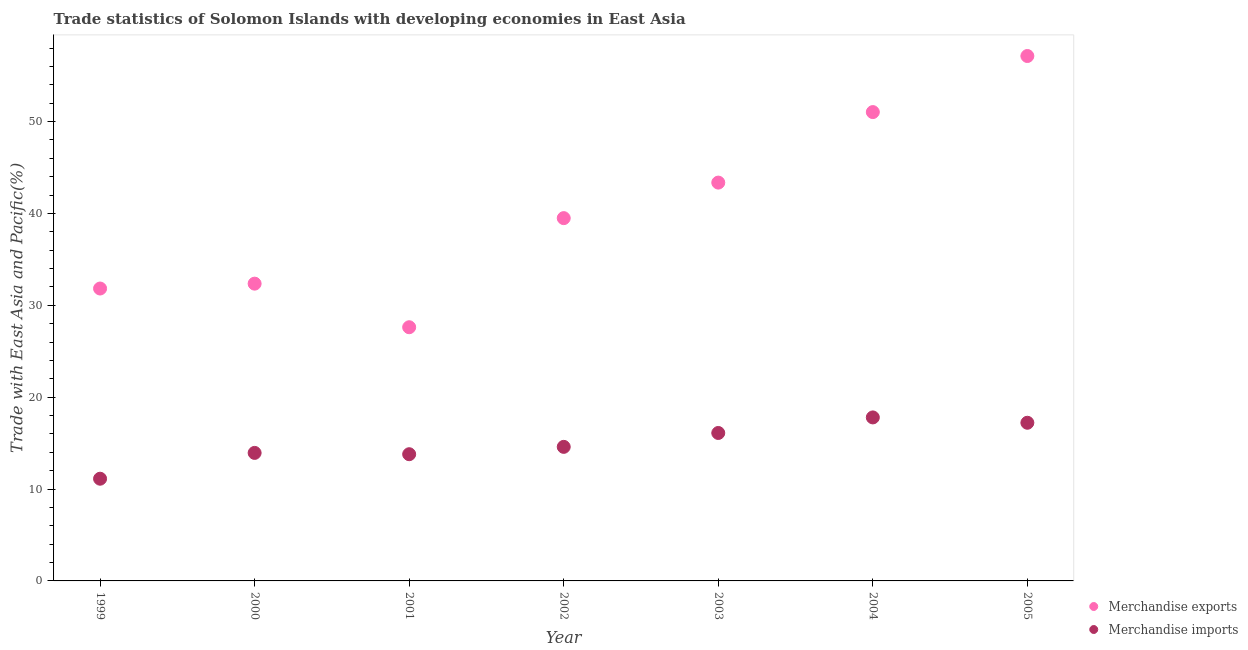What is the merchandise imports in 2001?
Provide a short and direct response. 13.79. Across all years, what is the maximum merchandise imports?
Your answer should be compact. 17.79. Across all years, what is the minimum merchandise exports?
Offer a terse response. 27.61. What is the total merchandise exports in the graph?
Your answer should be compact. 282.77. What is the difference between the merchandise exports in 2000 and that in 2004?
Offer a terse response. -18.67. What is the difference between the merchandise exports in 2002 and the merchandise imports in 2000?
Offer a very short reply. 25.55. What is the average merchandise imports per year?
Keep it short and to the point. 14.94. In the year 1999, what is the difference between the merchandise imports and merchandise exports?
Provide a succinct answer. -20.7. In how many years, is the merchandise exports greater than 28 %?
Offer a terse response. 6. What is the ratio of the merchandise imports in 2002 to that in 2004?
Provide a short and direct response. 0.82. What is the difference between the highest and the second highest merchandise imports?
Your answer should be very brief. 0.58. What is the difference between the highest and the lowest merchandise imports?
Ensure brevity in your answer.  6.67. Does the merchandise imports monotonically increase over the years?
Provide a succinct answer. No. Is the merchandise exports strictly less than the merchandise imports over the years?
Keep it short and to the point. No. How many dotlines are there?
Make the answer very short. 2. How many years are there in the graph?
Your answer should be compact. 7. Are the values on the major ticks of Y-axis written in scientific E-notation?
Keep it short and to the point. No. Does the graph contain grids?
Keep it short and to the point. No. How are the legend labels stacked?
Offer a very short reply. Vertical. What is the title of the graph?
Provide a succinct answer. Trade statistics of Solomon Islands with developing economies in East Asia. What is the label or title of the Y-axis?
Give a very brief answer. Trade with East Asia and Pacific(%). What is the Trade with East Asia and Pacific(%) in Merchandise exports in 1999?
Keep it short and to the point. 31.82. What is the Trade with East Asia and Pacific(%) of Merchandise imports in 1999?
Make the answer very short. 11.12. What is the Trade with East Asia and Pacific(%) of Merchandise exports in 2000?
Make the answer very short. 32.35. What is the Trade with East Asia and Pacific(%) of Merchandise imports in 2000?
Offer a terse response. 13.93. What is the Trade with East Asia and Pacific(%) in Merchandise exports in 2001?
Keep it short and to the point. 27.61. What is the Trade with East Asia and Pacific(%) in Merchandise imports in 2001?
Ensure brevity in your answer.  13.79. What is the Trade with East Asia and Pacific(%) in Merchandise exports in 2002?
Keep it short and to the point. 39.48. What is the Trade with East Asia and Pacific(%) in Merchandise imports in 2002?
Offer a terse response. 14.59. What is the Trade with East Asia and Pacific(%) of Merchandise exports in 2003?
Give a very brief answer. 43.35. What is the Trade with East Asia and Pacific(%) of Merchandise imports in 2003?
Keep it short and to the point. 16.1. What is the Trade with East Asia and Pacific(%) of Merchandise exports in 2004?
Your response must be concise. 51.03. What is the Trade with East Asia and Pacific(%) of Merchandise imports in 2004?
Your answer should be compact. 17.79. What is the Trade with East Asia and Pacific(%) in Merchandise exports in 2005?
Make the answer very short. 57.13. What is the Trade with East Asia and Pacific(%) in Merchandise imports in 2005?
Your answer should be very brief. 17.21. Across all years, what is the maximum Trade with East Asia and Pacific(%) of Merchandise exports?
Your answer should be compact. 57.13. Across all years, what is the maximum Trade with East Asia and Pacific(%) of Merchandise imports?
Provide a succinct answer. 17.79. Across all years, what is the minimum Trade with East Asia and Pacific(%) of Merchandise exports?
Your answer should be compact. 27.61. Across all years, what is the minimum Trade with East Asia and Pacific(%) in Merchandise imports?
Provide a succinct answer. 11.12. What is the total Trade with East Asia and Pacific(%) of Merchandise exports in the graph?
Your answer should be compact. 282.77. What is the total Trade with East Asia and Pacific(%) of Merchandise imports in the graph?
Provide a short and direct response. 104.55. What is the difference between the Trade with East Asia and Pacific(%) in Merchandise exports in 1999 and that in 2000?
Your answer should be compact. -0.53. What is the difference between the Trade with East Asia and Pacific(%) in Merchandise imports in 1999 and that in 2000?
Offer a terse response. -2.81. What is the difference between the Trade with East Asia and Pacific(%) of Merchandise exports in 1999 and that in 2001?
Your answer should be very brief. 4.21. What is the difference between the Trade with East Asia and Pacific(%) of Merchandise imports in 1999 and that in 2001?
Ensure brevity in your answer.  -2.67. What is the difference between the Trade with East Asia and Pacific(%) in Merchandise exports in 1999 and that in 2002?
Ensure brevity in your answer.  -7.66. What is the difference between the Trade with East Asia and Pacific(%) of Merchandise imports in 1999 and that in 2002?
Your answer should be very brief. -3.47. What is the difference between the Trade with East Asia and Pacific(%) of Merchandise exports in 1999 and that in 2003?
Keep it short and to the point. -11.53. What is the difference between the Trade with East Asia and Pacific(%) of Merchandise imports in 1999 and that in 2003?
Ensure brevity in your answer.  -4.98. What is the difference between the Trade with East Asia and Pacific(%) of Merchandise exports in 1999 and that in 2004?
Your answer should be compact. -19.2. What is the difference between the Trade with East Asia and Pacific(%) in Merchandise imports in 1999 and that in 2004?
Provide a succinct answer. -6.67. What is the difference between the Trade with East Asia and Pacific(%) in Merchandise exports in 1999 and that in 2005?
Your answer should be compact. -25.31. What is the difference between the Trade with East Asia and Pacific(%) of Merchandise imports in 1999 and that in 2005?
Your answer should be very brief. -6.09. What is the difference between the Trade with East Asia and Pacific(%) of Merchandise exports in 2000 and that in 2001?
Give a very brief answer. 4.74. What is the difference between the Trade with East Asia and Pacific(%) of Merchandise imports in 2000 and that in 2001?
Give a very brief answer. 0.14. What is the difference between the Trade with East Asia and Pacific(%) in Merchandise exports in 2000 and that in 2002?
Offer a very short reply. -7.13. What is the difference between the Trade with East Asia and Pacific(%) in Merchandise imports in 2000 and that in 2002?
Make the answer very short. -0.66. What is the difference between the Trade with East Asia and Pacific(%) in Merchandise exports in 2000 and that in 2003?
Offer a very short reply. -11. What is the difference between the Trade with East Asia and Pacific(%) in Merchandise imports in 2000 and that in 2003?
Your response must be concise. -2.17. What is the difference between the Trade with East Asia and Pacific(%) of Merchandise exports in 2000 and that in 2004?
Provide a short and direct response. -18.67. What is the difference between the Trade with East Asia and Pacific(%) in Merchandise imports in 2000 and that in 2004?
Your response must be concise. -3.86. What is the difference between the Trade with East Asia and Pacific(%) of Merchandise exports in 2000 and that in 2005?
Your response must be concise. -24.78. What is the difference between the Trade with East Asia and Pacific(%) in Merchandise imports in 2000 and that in 2005?
Offer a terse response. -3.28. What is the difference between the Trade with East Asia and Pacific(%) of Merchandise exports in 2001 and that in 2002?
Offer a very short reply. -11.87. What is the difference between the Trade with East Asia and Pacific(%) in Merchandise imports in 2001 and that in 2002?
Ensure brevity in your answer.  -0.8. What is the difference between the Trade with East Asia and Pacific(%) of Merchandise exports in 2001 and that in 2003?
Keep it short and to the point. -15.74. What is the difference between the Trade with East Asia and Pacific(%) of Merchandise imports in 2001 and that in 2003?
Your answer should be very brief. -2.31. What is the difference between the Trade with East Asia and Pacific(%) in Merchandise exports in 2001 and that in 2004?
Keep it short and to the point. -23.42. What is the difference between the Trade with East Asia and Pacific(%) in Merchandise imports in 2001 and that in 2004?
Keep it short and to the point. -4. What is the difference between the Trade with East Asia and Pacific(%) of Merchandise exports in 2001 and that in 2005?
Your answer should be compact. -29.52. What is the difference between the Trade with East Asia and Pacific(%) in Merchandise imports in 2001 and that in 2005?
Give a very brief answer. -3.42. What is the difference between the Trade with East Asia and Pacific(%) of Merchandise exports in 2002 and that in 2003?
Provide a succinct answer. -3.87. What is the difference between the Trade with East Asia and Pacific(%) of Merchandise imports in 2002 and that in 2003?
Offer a terse response. -1.51. What is the difference between the Trade with East Asia and Pacific(%) in Merchandise exports in 2002 and that in 2004?
Your response must be concise. -11.54. What is the difference between the Trade with East Asia and Pacific(%) of Merchandise imports in 2002 and that in 2004?
Your response must be concise. -3.2. What is the difference between the Trade with East Asia and Pacific(%) of Merchandise exports in 2002 and that in 2005?
Provide a succinct answer. -17.64. What is the difference between the Trade with East Asia and Pacific(%) of Merchandise imports in 2002 and that in 2005?
Provide a short and direct response. -2.62. What is the difference between the Trade with East Asia and Pacific(%) in Merchandise exports in 2003 and that in 2004?
Your answer should be compact. -7.67. What is the difference between the Trade with East Asia and Pacific(%) of Merchandise imports in 2003 and that in 2004?
Ensure brevity in your answer.  -1.69. What is the difference between the Trade with East Asia and Pacific(%) of Merchandise exports in 2003 and that in 2005?
Make the answer very short. -13.78. What is the difference between the Trade with East Asia and Pacific(%) in Merchandise imports in 2003 and that in 2005?
Ensure brevity in your answer.  -1.11. What is the difference between the Trade with East Asia and Pacific(%) in Merchandise exports in 2004 and that in 2005?
Provide a succinct answer. -6.1. What is the difference between the Trade with East Asia and Pacific(%) of Merchandise imports in 2004 and that in 2005?
Keep it short and to the point. 0.58. What is the difference between the Trade with East Asia and Pacific(%) of Merchandise exports in 1999 and the Trade with East Asia and Pacific(%) of Merchandise imports in 2000?
Your answer should be very brief. 17.89. What is the difference between the Trade with East Asia and Pacific(%) of Merchandise exports in 1999 and the Trade with East Asia and Pacific(%) of Merchandise imports in 2001?
Offer a terse response. 18.03. What is the difference between the Trade with East Asia and Pacific(%) of Merchandise exports in 1999 and the Trade with East Asia and Pacific(%) of Merchandise imports in 2002?
Offer a very short reply. 17.23. What is the difference between the Trade with East Asia and Pacific(%) of Merchandise exports in 1999 and the Trade with East Asia and Pacific(%) of Merchandise imports in 2003?
Your answer should be compact. 15.72. What is the difference between the Trade with East Asia and Pacific(%) of Merchandise exports in 1999 and the Trade with East Asia and Pacific(%) of Merchandise imports in 2004?
Provide a succinct answer. 14.03. What is the difference between the Trade with East Asia and Pacific(%) in Merchandise exports in 1999 and the Trade with East Asia and Pacific(%) in Merchandise imports in 2005?
Your answer should be compact. 14.61. What is the difference between the Trade with East Asia and Pacific(%) in Merchandise exports in 2000 and the Trade with East Asia and Pacific(%) in Merchandise imports in 2001?
Ensure brevity in your answer.  18.56. What is the difference between the Trade with East Asia and Pacific(%) of Merchandise exports in 2000 and the Trade with East Asia and Pacific(%) of Merchandise imports in 2002?
Your answer should be compact. 17.76. What is the difference between the Trade with East Asia and Pacific(%) of Merchandise exports in 2000 and the Trade with East Asia and Pacific(%) of Merchandise imports in 2003?
Ensure brevity in your answer.  16.25. What is the difference between the Trade with East Asia and Pacific(%) in Merchandise exports in 2000 and the Trade with East Asia and Pacific(%) in Merchandise imports in 2004?
Give a very brief answer. 14.56. What is the difference between the Trade with East Asia and Pacific(%) in Merchandise exports in 2000 and the Trade with East Asia and Pacific(%) in Merchandise imports in 2005?
Offer a very short reply. 15.14. What is the difference between the Trade with East Asia and Pacific(%) of Merchandise exports in 2001 and the Trade with East Asia and Pacific(%) of Merchandise imports in 2002?
Your response must be concise. 13.02. What is the difference between the Trade with East Asia and Pacific(%) in Merchandise exports in 2001 and the Trade with East Asia and Pacific(%) in Merchandise imports in 2003?
Offer a very short reply. 11.51. What is the difference between the Trade with East Asia and Pacific(%) of Merchandise exports in 2001 and the Trade with East Asia and Pacific(%) of Merchandise imports in 2004?
Offer a terse response. 9.82. What is the difference between the Trade with East Asia and Pacific(%) of Merchandise exports in 2001 and the Trade with East Asia and Pacific(%) of Merchandise imports in 2005?
Ensure brevity in your answer.  10.4. What is the difference between the Trade with East Asia and Pacific(%) in Merchandise exports in 2002 and the Trade with East Asia and Pacific(%) in Merchandise imports in 2003?
Your answer should be compact. 23.38. What is the difference between the Trade with East Asia and Pacific(%) in Merchandise exports in 2002 and the Trade with East Asia and Pacific(%) in Merchandise imports in 2004?
Your answer should be very brief. 21.69. What is the difference between the Trade with East Asia and Pacific(%) in Merchandise exports in 2002 and the Trade with East Asia and Pacific(%) in Merchandise imports in 2005?
Offer a very short reply. 22.27. What is the difference between the Trade with East Asia and Pacific(%) of Merchandise exports in 2003 and the Trade with East Asia and Pacific(%) of Merchandise imports in 2004?
Make the answer very short. 25.56. What is the difference between the Trade with East Asia and Pacific(%) of Merchandise exports in 2003 and the Trade with East Asia and Pacific(%) of Merchandise imports in 2005?
Offer a terse response. 26.14. What is the difference between the Trade with East Asia and Pacific(%) of Merchandise exports in 2004 and the Trade with East Asia and Pacific(%) of Merchandise imports in 2005?
Keep it short and to the point. 33.81. What is the average Trade with East Asia and Pacific(%) of Merchandise exports per year?
Provide a succinct answer. 40.4. What is the average Trade with East Asia and Pacific(%) of Merchandise imports per year?
Make the answer very short. 14.94. In the year 1999, what is the difference between the Trade with East Asia and Pacific(%) of Merchandise exports and Trade with East Asia and Pacific(%) of Merchandise imports?
Give a very brief answer. 20.7. In the year 2000, what is the difference between the Trade with East Asia and Pacific(%) in Merchandise exports and Trade with East Asia and Pacific(%) in Merchandise imports?
Make the answer very short. 18.42. In the year 2001, what is the difference between the Trade with East Asia and Pacific(%) of Merchandise exports and Trade with East Asia and Pacific(%) of Merchandise imports?
Provide a succinct answer. 13.82. In the year 2002, what is the difference between the Trade with East Asia and Pacific(%) in Merchandise exports and Trade with East Asia and Pacific(%) in Merchandise imports?
Give a very brief answer. 24.89. In the year 2003, what is the difference between the Trade with East Asia and Pacific(%) of Merchandise exports and Trade with East Asia and Pacific(%) of Merchandise imports?
Ensure brevity in your answer.  27.25. In the year 2004, what is the difference between the Trade with East Asia and Pacific(%) in Merchandise exports and Trade with East Asia and Pacific(%) in Merchandise imports?
Give a very brief answer. 33.23. In the year 2005, what is the difference between the Trade with East Asia and Pacific(%) of Merchandise exports and Trade with East Asia and Pacific(%) of Merchandise imports?
Provide a succinct answer. 39.91. What is the ratio of the Trade with East Asia and Pacific(%) in Merchandise exports in 1999 to that in 2000?
Your answer should be very brief. 0.98. What is the ratio of the Trade with East Asia and Pacific(%) of Merchandise imports in 1999 to that in 2000?
Provide a succinct answer. 0.8. What is the ratio of the Trade with East Asia and Pacific(%) in Merchandise exports in 1999 to that in 2001?
Give a very brief answer. 1.15. What is the ratio of the Trade with East Asia and Pacific(%) of Merchandise imports in 1999 to that in 2001?
Offer a very short reply. 0.81. What is the ratio of the Trade with East Asia and Pacific(%) of Merchandise exports in 1999 to that in 2002?
Your answer should be very brief. 0.81. What is the ratio of the Trade with East Asia and Pacific(%) in Merchandise imports in 1999 to that in 2002?
Keep it short and to the point. 0.76. What is the ratio of the Trade with East Asia and Pacific(%) in Merchandise exports in 1999 to that in 2003?
Provide a succinct answer. 0.73. What is the ratio of the Trade with East Asia and Pacific(%) in Merchandise imports in 1999 to that in 2003?
Keep it short and to the point. 0.69. What is the ratio of the Trade with East Asia and Pacific(%) of Merchandise exports in 1999 to that in 2004?
Your answer should be compact. 0.62. What is the ratio of the Trade with East Asia and Pacific(%) in Merchandise imports in 1999 to that in 2004?
Your answer should be compact. 0.63. What is the ratio of the Trade with East Asia and Pacific(%) of Merchandise exports in 1999 to that in 2005?
Ensure brevity in your answer.  0.56. What is the ratio of the Trade with East Asia and Pacific(%) in Merchandise imports in 1999 to that in 2005?
Your response must be concise. 0.65. What is the ratio of the Trade with East Asia and Pacific(%) in Merchandise exports in 2000 to that in 2001?
Offer a very short reply. 1.17. What is the ratio of the Trade with East Asia and Pacific(%) in Merchandise imports in 2000 to that in 2001?
Your response must be concise. 1.01. What is the ratio of the Trade with East Asia and Pacific(%) in Merchandise exports in 2000 to that in 2002?
Keep it short and to the point. 0.82. What is the ratio of the Trade with East Asia and Pacific(%) of Merchandise imports in 2000 to that in 2002?
Provide a succinct answer. 0.95. What is the ratio of the Trade with East Asia and Pacific(%) of Merchandise exports in 2000 to that in 2003?
Offer a very short reply. 0.75. What is the ratio of the Trade with East Asia and Pacific(%) of Merchandise imports in 2000 to that in 2003?
Provide a succinct answer. 0.87. What is the ratio of the Trade with East Asia and Pacific(%) in Merchandise exports in 2000 to that in 2004?
Make the answer very short. 0.63. What is the ratio of the Trade with East Asia and Pacific(%) of Merchandise imports in 2000 to that in 2004?
Make the answer very short. 0.78. What is the ratio of the Trade with East Asia and Pacific(%) of Merchandise exports in 2000 to that in 2005?
Offer a terse response. 0.57. What is the ratio of the Trade with East Asia and Pacific(%) in Merchandise imports in 2000 to that in 2005?
Keep it short and to the point. 0.81. What is the ratio of the Trade with East Asia and Pacific(%) in Merchandise exports in 2001 to that in 2002?
Provide a short and direct response. 0.7. What is the ratio of the Trade with East Asia and Pacific(%) in Merchandise imports in 2001 to that in 2002?
Ensure brevity in your answer.  0.95. What is the ratio of the Trade with East Asia and Pacific(%) of Merchandise exports in 2001 to that in 2003?
Your response must be concise. 0.64. What is the ratio of the Trade with East Asia and Pacific(%) of Merchandise imports in 2001 to that in 2003?
Provide a succinct answer. 0.86. What is the ratio of the Trade with East Asia and Pacific(%) of Merchandise exports in 2001 to that in 2004?
Your response must be concise. 0.54. What is the ratio of the Trade with East Asia and Pacific(%) of Merchandise imports in 2001 to that in 2004?
Offer a very short reply. 0.78. What is the ratio of the Trade with East Asia and Pacific(%) of Merchandise exports in 2001 to that in 2005?
Provide a short and direct response. 0.48. What is the ratio of the Trade with East Asia and Pacific(%) of Merchandise imports in 2001 to that in 2005?
Make the answer very short. 0.8. What is the ratio of the Trade with East Asia and Pacific(%) of Merchandise exports in 2002 to that in 2003?
Offer a terse response. 0.91. What is the ratio of the Trade with East Asia and Pacific(%) of Merchandise imports in 2002 to that in 2003?
Ensure brevity in your answer.  0.91. What is the ratio of the Trade with East Asia and Pacific(%) in Merchandise exports in 2002 to that in 2004?
Your answer should be very brief. 0.77. What is the ratio of the Trade with East Asia and Pacific(%) in Merchandise imports in 2002 to that in 2004?
Your answer should be very brief. 0.82. What is the ratio of the Trade with East Asia and Pacific(%) in Merchandise exports in 2002 to that in 2005?
Provide a short and direct response. 0.69. What is the ratio of the Trade with East Asia and Pacific(%) in Merchandise imports in 2002 to that in 2005?
Make the answer very short. 0.85. What is the ratio of the Trade with East Asia and Pacific(%) in Merchandise exports in 2003 to that in 2004?
Provide a short and direct response. 0.85. What is the ratio of the Trade with East Asia and Pacific(%) in Merchandise imports in 2003 to that in 2004?
Give a very brief answer. 0.9. What is the ratio of the Trade with East Asia and Pacific(%) in Merchandise exports in 2003 to that in 2005?
Ensure brevity in your answer.  0.76. What is the ratio of the Trade with East Asia and Pacific(%) in Merchandise imports in 2003 to that in 2005?
Your response must be concise. 0.94. What is the ratio of the Trade with East Asia and Pacific(%) of Merchandise exports in 2004 to that in 2005?
Your response must be concise. 0.89. What is the ratio of the Trade with East Asia and Pacific(%) of Merchandise imports in 2004 to that in 2005?
Offer a very short reply. 1.03. What is the difference between the highest and the second highest Trade with East Asia and Pacific(%) in Merchandise exports?
Make the answer very short. 6.1. What is the difference between the highest and the second highest Trade with East Asia and Pacific(%) of Merchandise imports?
Give a very brief answer. 0.58. What is the difference between the highest and the lowest Trade with East Asia and Pacific(%) in Merchandise exports?
Your answer should be very brief. 29.52. What is the difference between the highest and the lowest Trade with East Asia and Pacific(%) of Merchandise imports?
Your answer should be compact. 6.67. 